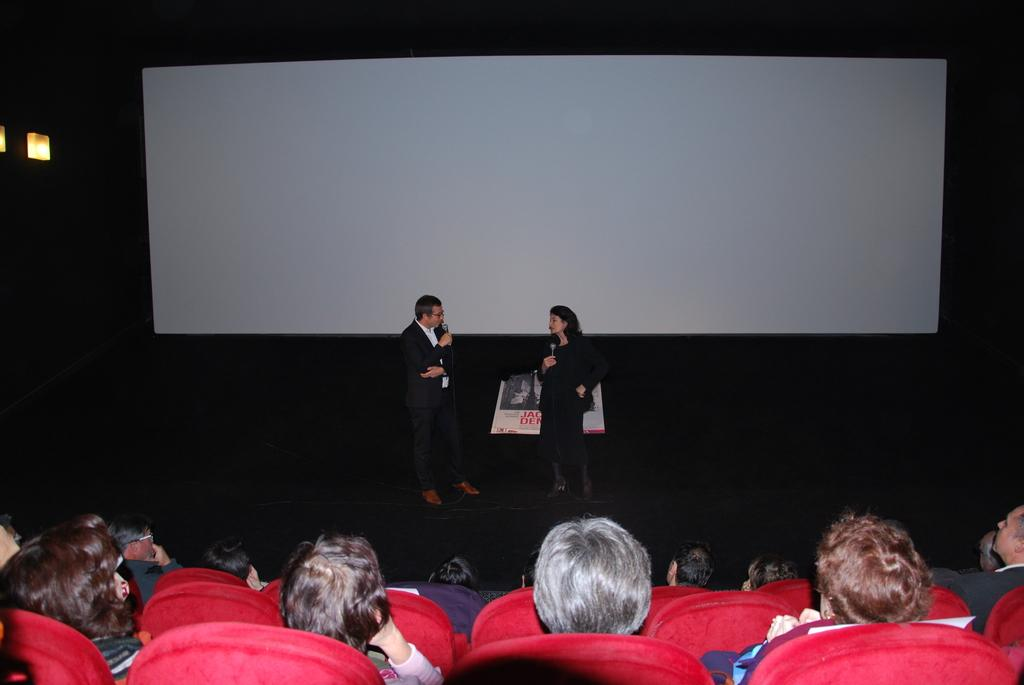What are the people in the image doing? There is a group of people sitting in the image, which suggests they might be attending an event or gathering. Can you describe the people in the background? There are two people standing in the background, and they are holding microphones, which might indicate they are speakers or performers. What can be seen on the screen in the image? The facts do not specify what is on the screen, so we cannot answer this question definitively. What type of lighting is present in the image? There are lights present in the image, but the specific type of lighting is not mentioned in the facts. How many tastes can be identified in the image? There is no information about tastes in the image, as it does not involve food or flavors. What is the amount of organization present in the image? The facts do not mention any specific level of organization in the image, so we cannot answer this question definitively. 